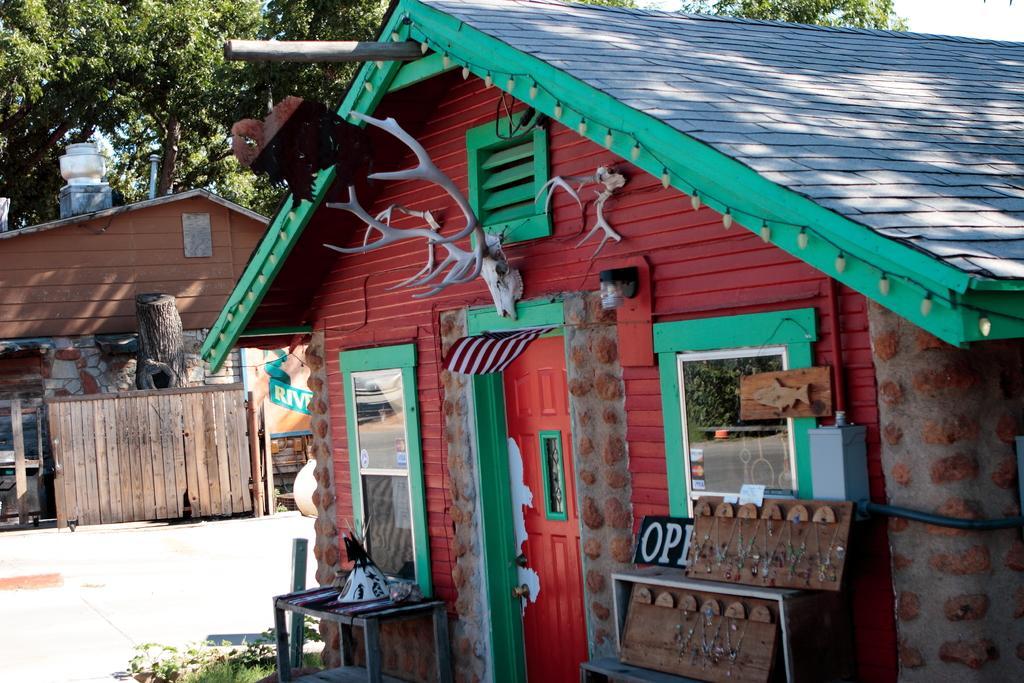How would you summarize this image in a sentence or two? In this image, we can see sculptures and mirrors to a shed and there are boards and some other objects on the stand. In the background, there are trees and we can see another shed and there are some plants and we can see a fence and a tree trunk. At the bottom, there is a road. 